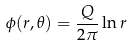Convert formula to latex. <formula><loc_0><loc_0><loc_500><loc_500>\phi ( r , \theta ) = \frac { Q } { 2 \pi } \ln r</formula> 